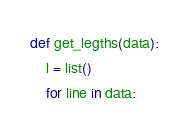Convert code to text. <code><loc_0><loc_0><loc_500><loc_500><_Python_>def get_legths(data):
    l = list()
    for line in data:</code> 